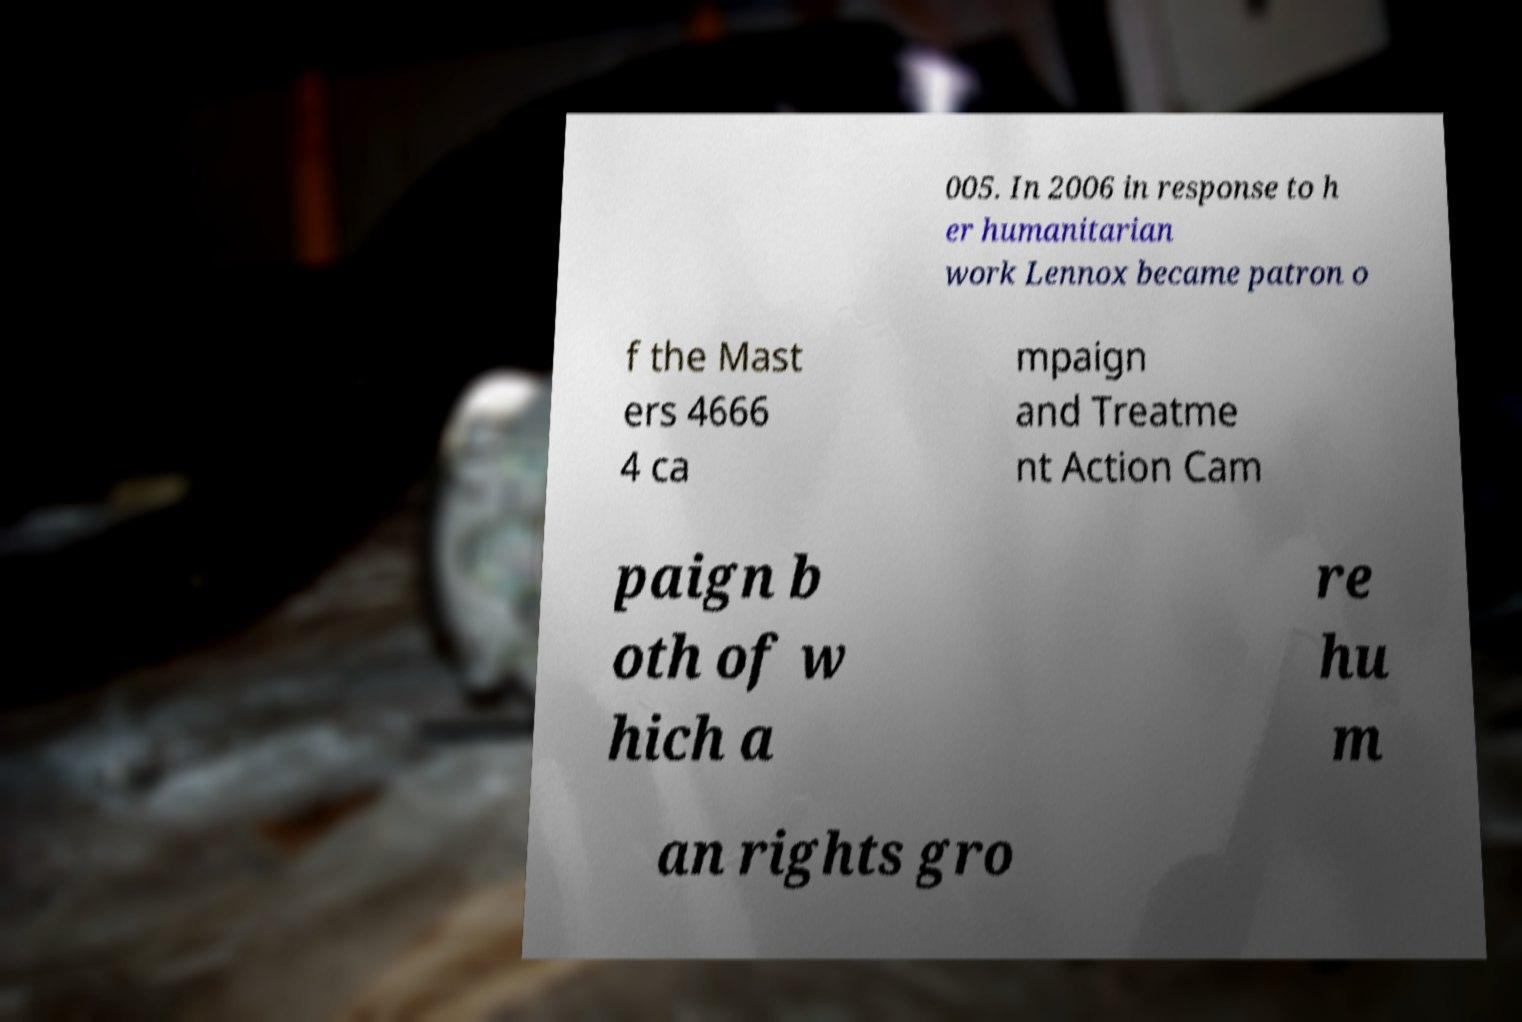What messages or text are displayed in this image? I need them in a readable, typed format. 005. In 2006 in response to h er humanitarian work Lennox became patron o f the Mast ers 4666 4 ca mpaign and Treatme nt Action Cam paign b oth of w hich a re hu m an rights gro 